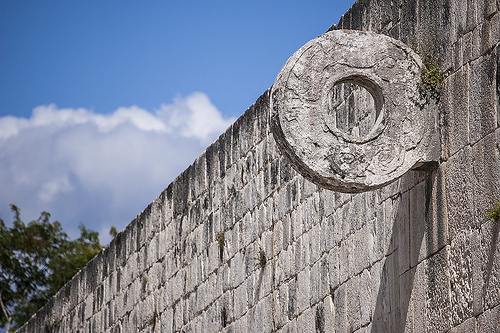<image>
Can you confirm if the sky is behind the wall? Yes. From this viewpoint, the sky is positioned behind the wall, with the wall partially or fully occluding the sky. Is there a ring next to the sky? No. The ring is not positioned next to the sky. They are located in different areas of the scene. 